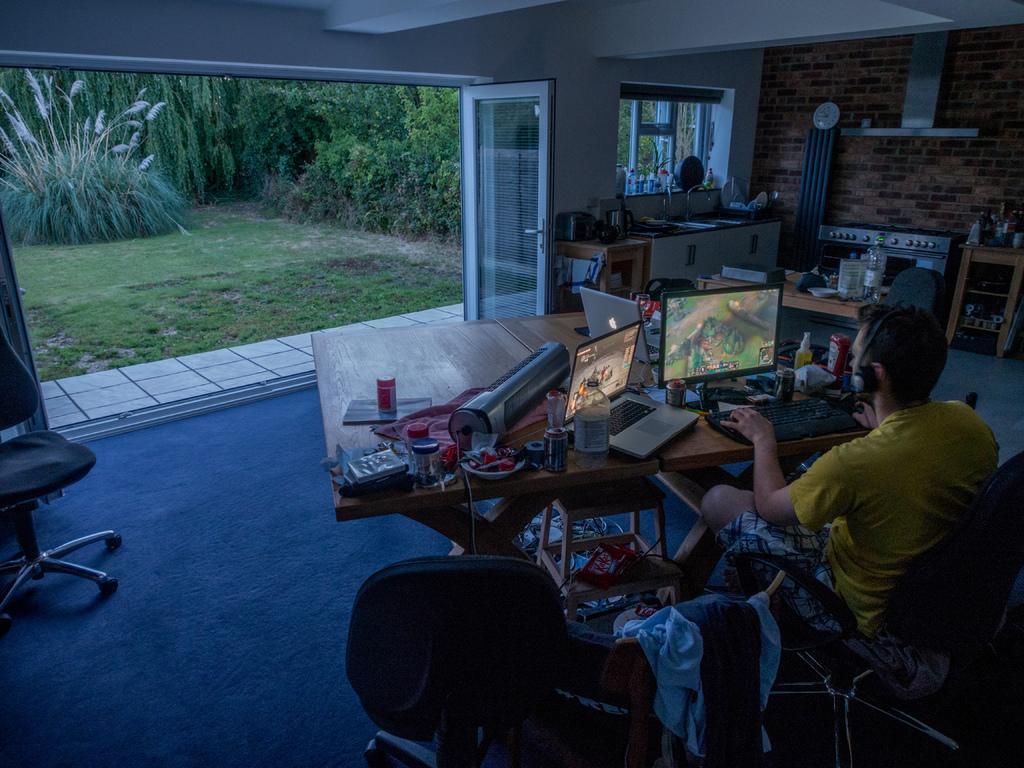Can you describe this image briefly? This picture is inside view of a room. We can see some objects, laptop, screen, monitor, bottle are present on the table. A person is sitting on a chair and wearing a headset. At the bottom of the image we can see some chairs, tablecloths are present. At the top of the image we can see a roof, clock are there. On the left side of the image we can see some bushes, trees, grass are there. In the middle of the image a door is there. 